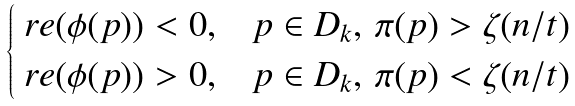<formula> <loc_0><loc_0><loc_500><loc_500>\begin{cases} \ r e ( \phi ( p ) ) < 0 , & p \in D _ { k } , \, \pi ( p ) > \zeta ( n / t ) \\ \ r e ( \phi ( p ) ) > 0 , & p \in D _ { k } , \, \pi ( p ) < \zeta ( n / t ) \end{cases}</formula> 